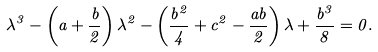Convert formula to latex. <formula><loc_0><loc_0><loc_500><loc_500>\lambda ^ { 3 } - \left ( a + \frac { b } { 2 } \right ) \lambda ^ { 2 } - \left ( \frac { b ^ { 2 } } { 4 } + c ^ { 2 } - \frac { a b } { 2 } \right ) \lambda + \frac { b ^ { 3 } } { 8 } = 0 .</formula> 